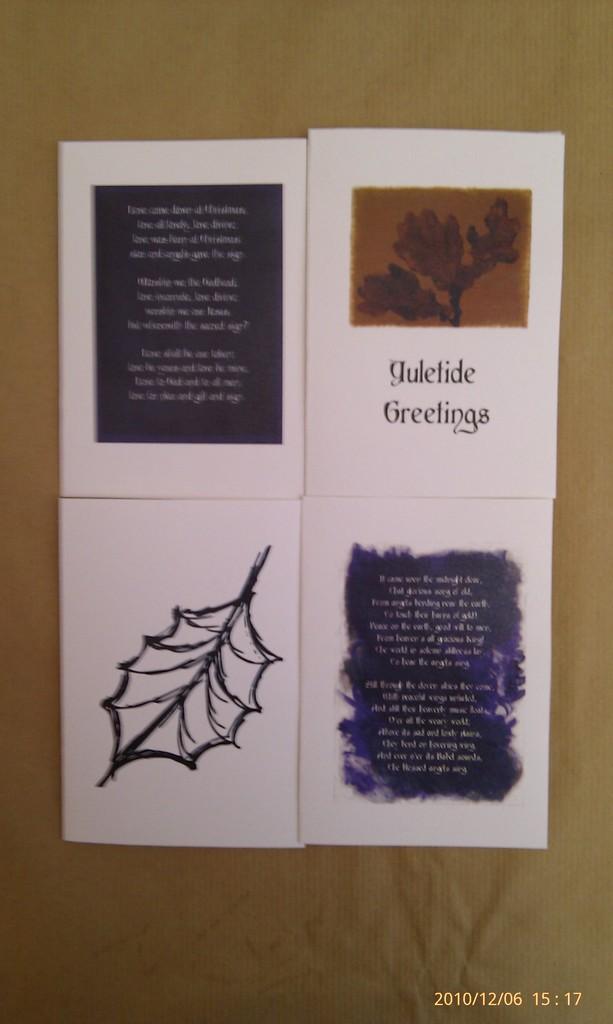What kind of greetings does the card mention?
Make the answer very short. Yuletide. What year this picture was taken?
Provide a succinct answer. 2010. 